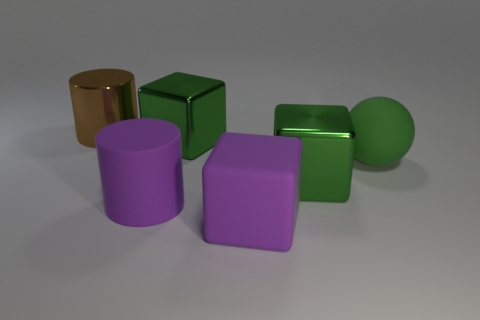Is there any other thing that is the same shape as the green rubber object?
Keep it short and to the point. No. There is a cube that is made of the same material as the purple cylinder; what is its color?
Make the answer very short. Purple. What number of green things are the same material as the big brown thing?
Keep it short and to the point. 2. How many things are brown shiny cylinders or big green matte balls that are behind the large purple rubber cylinder?
Offer a very short reply. 2. Does the large green cube in front of the large green matte object have the same material as the large purple cylinder?
Offer a very short reply. No. What is the color of the matte cube that is the same size as the brown thing?
Make the answer very short. Purple. Is there another matte thing that has the same shape as the brown thing?
Your answer should be compact. Yes. There is a cube that is in front of the big cylinder on the right side of the big cylinder behind the big purple cylinder; what is its color?
Give a very brief answer. Purple. What number of metallic things are either big brown cylinders or blue cylinders?
Make the answer very short. 1. Are there more matte cylinders in front of the matte ball than large green spheres that are on the left side of the big purple block?
Offer a terse response. Yes. 